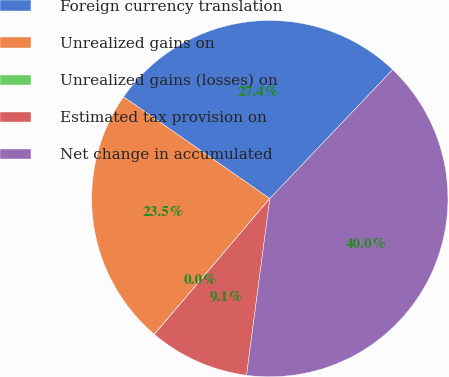<chart> <loc_0><loc_0><loc_500><loc_500><pie_chart><fcel>Foreign currency translation<fcel>Unrealized gains on<fcel>Unrealized gains (losses) on<fcel>Estimated tax provision on<fcel>Net change in accumulated<nl><fcel>27.44%<fcel>23.45%<fcel>0.01%<fcel>9.13%<fcel>39.97%<nl></chart> 